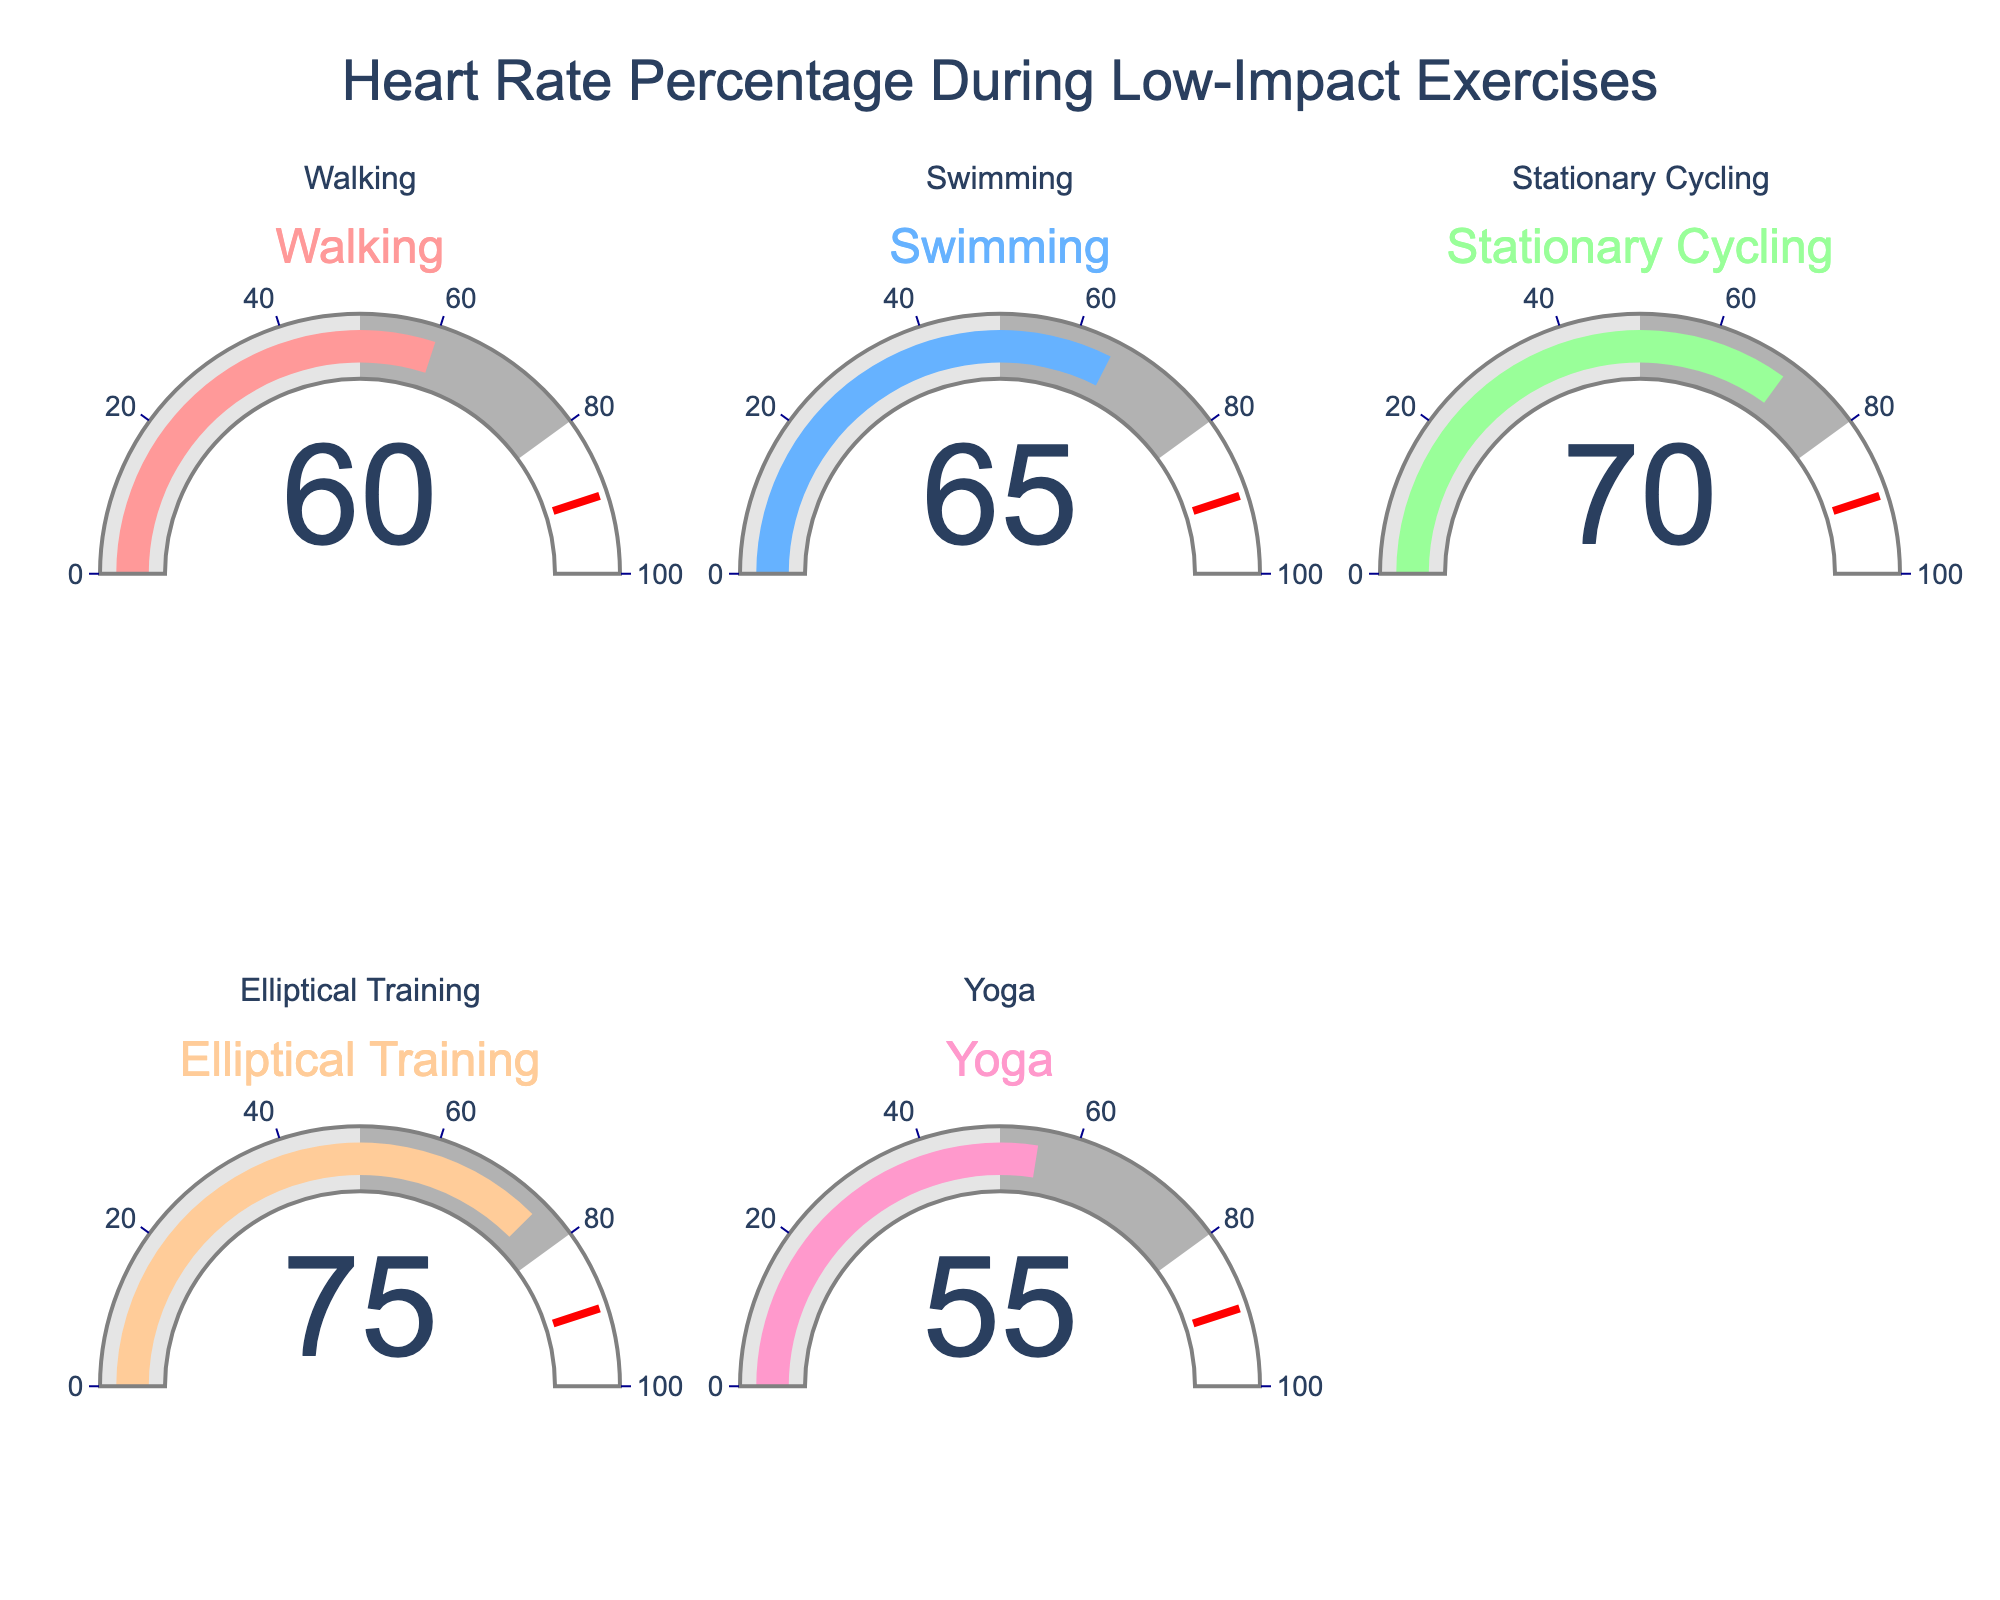What's the title of the chart? The title is usually located at the top of the chart. In this case, it's "Heart Rate Percentage During Low-Impact Exercises."
Answer: Heart Rate Percentage During Low-Impact Exercises Which exercise has the highest percentage of maximum heart rate achieved? By looking at the values displayed on each gauge, the exercise with the highest percentage can be identified. "Elliptical Training" has a percentage of 75%.
Answer: Elliptical Training Which exercise has the lowest percentage of maximum heart rate achieved? By comparing all the values on the gauges, "Yoga" displays the lowest percentage, which is 55%.
Answer: Yoga What's the average percentage of maximum heart rate achieved for all the exercises? To find the average, sum all the percentages and divide by the number of exercises. Sum = 60 + 65 + 70 + 75 + 55 = 325. The number of exercises is 5. So, the average is 325/5 = 65%
Answer: 65% How much higher is the percentage for Elliptical Training compared to Yoga? Subtract the percentage for Yoga from the percentage for Elliptical Training: 75% - 55% = 20%
Answer: 20% What's the range of percentages displayed in the chart? The range is calculated by taking the highest percentage and subtracting the lowest percentage. The highest is 75% (Elliptical Training) and the lowest is 55% (Yoga). So, the range is 75% - 55% = 20%
Answer: 20% What is the median value of the percentage of maximum heart rate achieved? To find the median, list the percentages in ascending order: 55, 60, 65, 70, 75. The median is the middle number, which is 65%
Answer: 65% How many exercises achieve a percentage of 70% or higher? By examining the values on the gauges, we see that Stationary Cycling (70%), Elliptical Training (75%), and Swimming (65%). Thus, there are 2 values that are 70% or higher.
Answer: 2 What percentage of the exercises achieve a percentage of maximum heart rate between 60% and 70% (inclusive)? Count the exercises falling within 60-70%, which are Walking (60%), and Stationary Cycling (70%). This makes 2 out of 5 exercises. The percentage is (2/5) * 100 = 40%
Answer: 40% What's the difference between the percentage for Swimming and Stationary Cycling? Subtract the percentage of Swimming from Stationary Cycling: 70% - 65% = 5%
Answer: 5% 